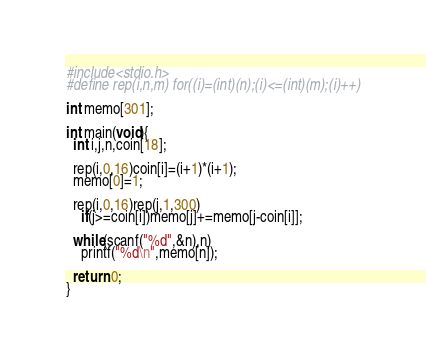<code> <loc_0><loc_0><loc_500><loc_500><_C_>#include<stdio.h>
#define rep(i,n,m) for((i)=(int)(n);(i)<=(int)(m);(i)++)

int memo[301];

int main(void){
  int i,j,n,coin[18];

  rep(i,0,16)coin[i]=(i+1)*(i+1);
  memo[0]=1;

  rep(i,0,16)rep(j,1,300)
    if(j>=coin[i])memo[j]+=memo[j-coin[i]];
  
  while(scanf("%d",&n),n)
    printf("%d\n",memo[n]);
  
  return 0;
}</code> 